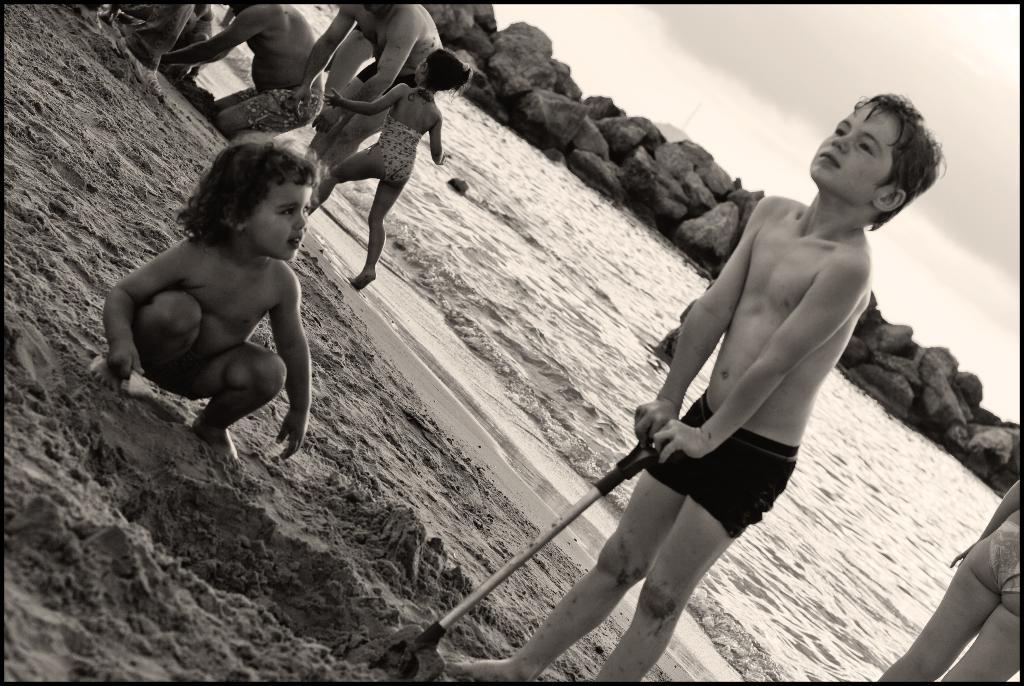What are the kids doing in the image? The kids are playing in the sand. What can be seen in the background of the image? There is water and big stones visible in the background. What is the condition of the sky in the image? Clouds are present in the sky. What type of learning material can be seen near the kids? There is no learning material visible near the kids in the image. What force is being applied to the hydrant in the image? There is no hydrant present in the image. 